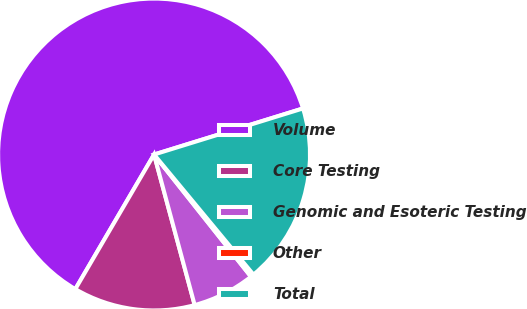Convert chart to OTSL. <chart><loc_0><loc_0><loc_500><loc_500><pie_chart><fcel>Volume<fcel>Core Testing<fcel>Genomic and Esoteric Testing<fcel>Other<fcel>Total<nl><fcel>61.8%<fcel>12.62%<fcel>6.48%<fcel>0.33%<fcel>18.77%<nl></chart> 